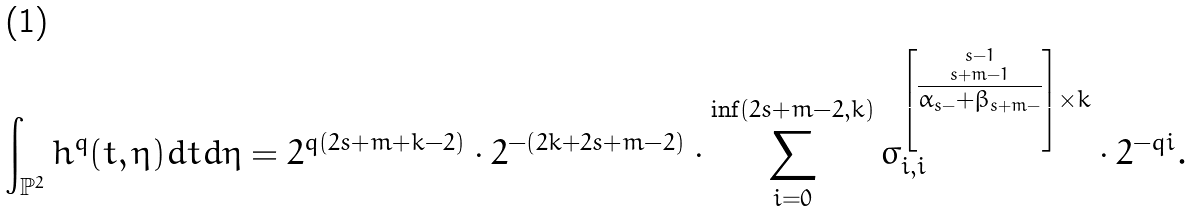<formula> <loc_0><loc_0><loc_500><loc_500>\int _ { \mathbb { P } ^ { 2 } } h ^ { q } ( t , \eta ) d t d \eta = 2 ^ { q ( 2 s + m + k - 2 ) } \cdot 2 ^ { - ( 2 k + 2 s + m - 2 ) } \cdot \sum _ { i = 0 } ^ { \inf ( 2 s + m - 2 , k ) } \sigma _ { i , i } ^ { \left [ \stackrel { s - 1 } { \stackrel { s + m - 1 } { \overline { \alpha _ { s - } + \beta _ { s + m - } } } } \right ] \times k } \cdot 2 ^ { - q i } .</formula> 